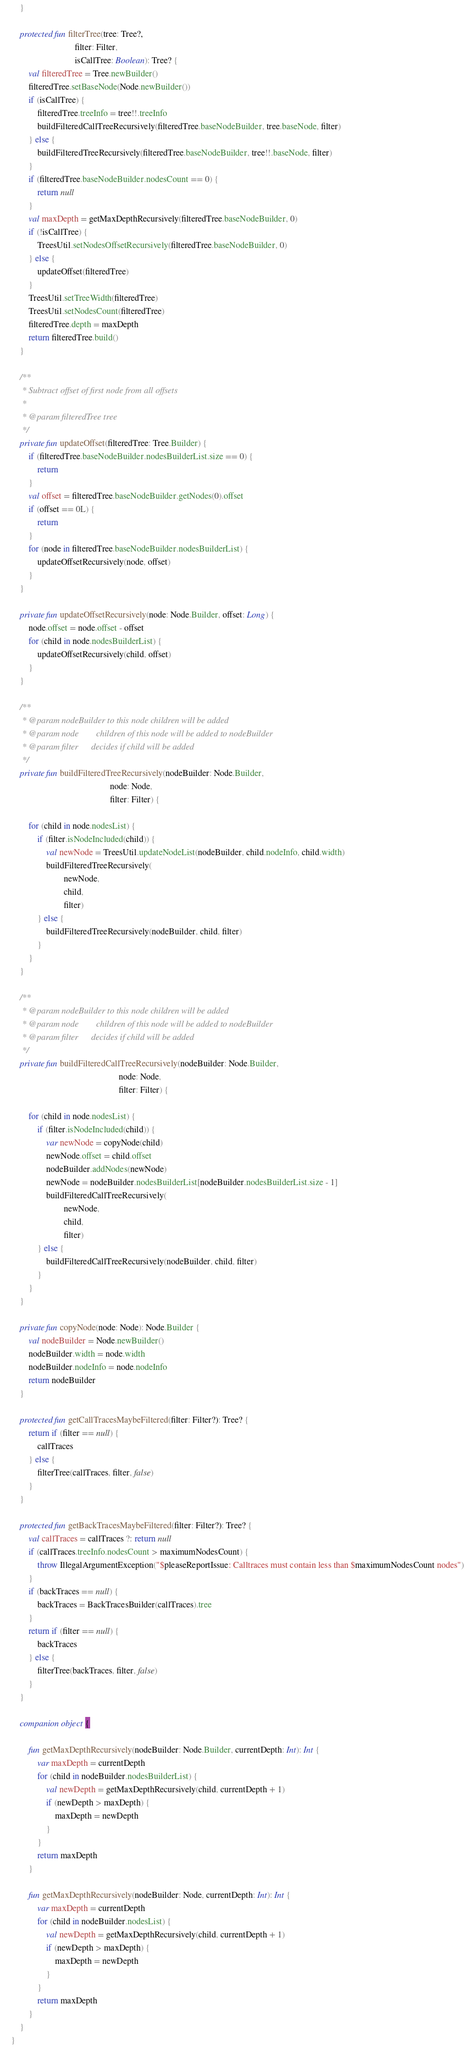<code> <loc_0><loc_0><loc_500><loc_500><_Kotlin_>    }

    protected fun filterTree(tree: Tree?,
                             filter: Filter,
                             isCallTree: Boolean): Tree? {
        val filteredTree = Tree.newBuilder()
        filteredTree.setBaseNode(Node.newBuilder())
        if (isCallTree) {
            filteredTree.treeInfo = tree!!.treeInfo
            buildFilteredCallTreeRecursively(filteredTree.baseNodeBuilder, tree.baseNode, filter)
        } else {
            buildFilteredTreeRecursively(filteredTree.baseNodeBuilder, tree!!.baseNode, filter)
        }
        if (filteredTree.baseNodeBuilder.nodesCount == 0) {
            return null
        }
        val maxDepth = getMaxDepthRecursively(filteredTree.baseNodeBuilder, 0)
        if (!isCallTree) {
            TreesUtil.setNodesOffsetRecursively(filteredTree.baseNodeBuilder, 0)
        } else {
            updateOffset(filteredTree)
        }
        TreesUtil.setTreeWidth(filteredTree)
        TreesUtil.setNodesCount(filteredTree)
        filteredTree.depth = maxDepth
        return filteredTree.build()
    }

    /**
     * Subtract offset of first node from all offsets
     *
     * @param filteredTree tree
     */
    private fun updateOffset(filteredTree: Tree.Builder) {
        if (filteredTree.baseNodeBuilder.nodesBuilderList.size == 0) {
            return
        }
        val offset = filteredTree.baseNodeBuilder.getNodes(0).offset
        if (offset == 0L) {
            return
        }
        for (node in filteredTree.baseNodeBuilder.nodesBuilderList) {
            updateOffsetRecursively(node, offset)
        }
    }

    private fun updateOffsetRecursively(node: Node.Builder, offset: Long) {
        node.offset = node.offset - offset
        for (child in node.nodesBuilderList) {
            updateOffsetRecursively(child, offset)
        }
    }

    /**
     * @param nodeBuilder to this node children will be added
     * @param node        children of this node will be added to nodeBuilder
     * @param filter      decides if child will be added
     */
    private fun buildFilteredTreeRecursively(nodeBuilder: Node.Builder,
                                             node: Node,
                                             filter: Filter) {

        for (child in node.nodesList) {
            if (filter.isNodeIncluded(child)) {
                val newNode = TreesUtil.updateNodeList(nodeBuilder, child.nodeInfo, child.width)
                buildFilteredTreeRecursively(
                        newNode,
                        child,
                        filter)
            } else {
                buildFilteredTreeRecursively(nodeBuilder, child, filter)
            }
        }
    }

    /**
     * @param nodeBuilder to this node children will be added
     * @param node        children of this node will be added to nodeBuilder
     * @param filter      decides if child will be added
     */
    private fun buildFilteredCallTreeRecursively(nodeBuilder: Node.Builder,
                                                 node: Node,
                                                 filter: Filter) {

        for (child in node.nodesList) {
            if (filter.isNodeIncluded(child)) {
                var newNode = copyNode(child)
                newNode.offset = child.offset
                nodeBuilder.addNodes(newNode)
                newNode = nodeBuilder.nodesBuilderList[nodeBuilder.nodesBuilderList.size - 1]
                buildFilteredCallTreeRecursively(
                        newNode,
                        child,
                        filter)
            } else {
                buildFilteredCallTreeRecursively(nodeBuilder, child, filter)
            }
        }
    }

    private fun copyNode(node: Node): Node.Builder {
        val nodeBuilder = Node.newBuilder()
        nodeBuilder.width = node.width
        nodeBuilder.nodeInfo = node.nodeInfo
        return nodeBuilder
    }

    protected fun getCallTracesMaybeFiltered(filter: Filter?): Tree? {
        return if (filter == null) {
            callTraces
        } else {
            filterTree(callTraces, filter, false)
        }
    }

    protected fun getBackTracesMaybeFiltered(filter: Filter?): Tree? {
        val callTraces = callTraces ?: return null
        if (callTraces.treeInfo.nodesCount > maximumNodesCount) {
            throw IllegalArgumentException("$pleaseReportIssue: Calltraces must contain less than $maximumNodesCount nodes")
        }
        if (backTraces == null) {
            backTraces = BackTracesBuilder(callTraces).tree
        }
        return if (filter == null) {
            backTraces
        } else {
            filterTree(backTraces, filter, false)
        }
    }

    companion object {

        fun getMaxDepthRecursively(nodeBuilder: Node.Builder, currentDepth: Int): Int {
            var maxDepth = currentDepth
            for (child in nodeBuilder.nodesBuilderList) {
                val newDepth = getMaxDepthRecursively(child, currentDepth + 1)
                if (newDepth > maxDepth) {
                    maxDepth = newDepth
                }
            }
            return maxDepth
        }

        fun getMaxDepthRecursively(nodeBuilder: Node, currentDepth: Int): Int {
            var maxDepth = currentDepth
            for (child in nodeBuilder.nodesList) {
                val newDepth = getMaxDepthRecursively(child, currentDepth + 1)
                if (newDepth > maxDepth) {
                    maxDepth = newDepth
                }
            }
            return maxDepth
        }
    }
}
</code> 